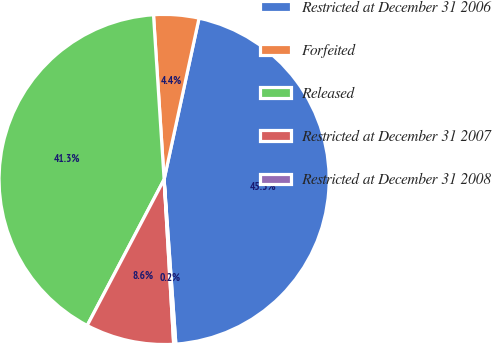Convert chart. <chart><loc_0><loc_0><loc_500><loc_500><pie_chart><fcel>Restricted at December 31 2006<fcel>Forfeited<fcel>Released<fcel>Restricted at December 31 2007<fcel>Restricted at December 31 2008<nl><fcel>45.47%<fcel>4.42%<fcel>41.26%<fcel>8.64%<fcel>0.21%<nl></chart> 